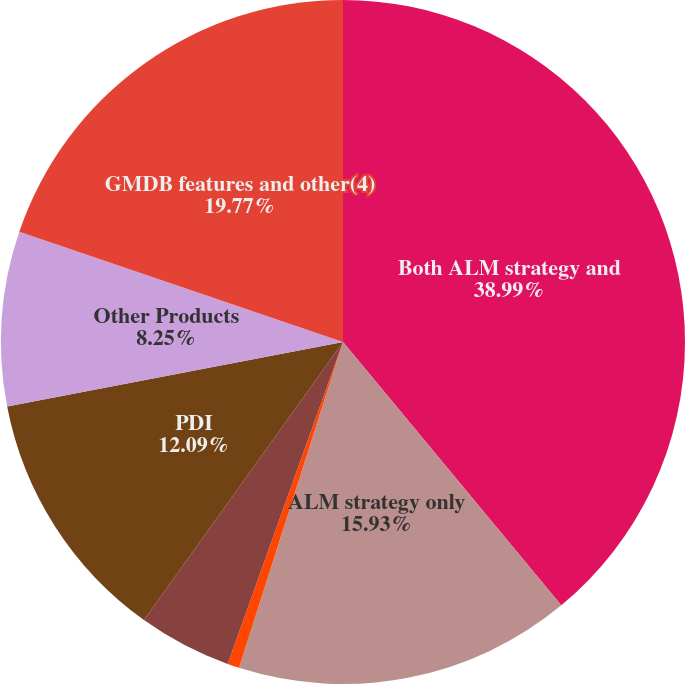Convert chart. <chart><loc_0><loc_0><loc_500><loc_500><pie_chart><fcel>Both ALM strategy and<fcel>ALM strategy only<fcel>Automatic rebalancing only<fcel>External reinsurance(3)<fcel>PDI<fcel>Other Products<fcel>GMDB features and other(4)<nl><fcel>38.98%<fcel>15.93%<fcel>0.56%<fcel>4.41%<fcel>12.09%<fcel>8.25%<fcel>19.77%<nl></chart> 